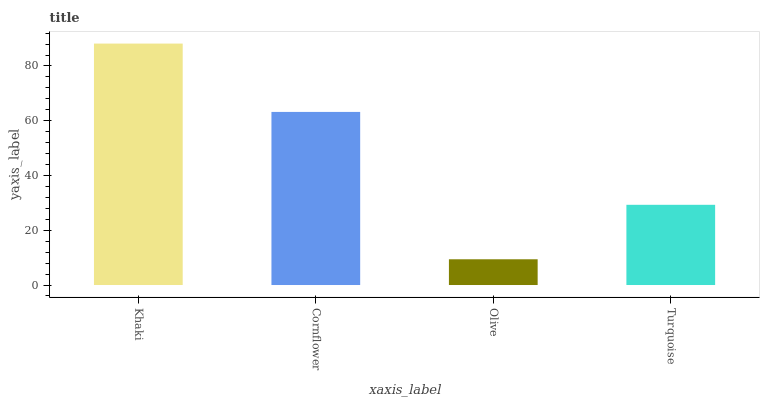Is Olive the minimum?
Answer yes or no. Yes. Is Khaki the maximum?
Answer yes or no. Yes. Is Cornflower the minimum?
Answer yes or no. No. Is Cornflower the maximum?
Answer yes or no. No. Is Khaki greater than Cornflower?
Answer yes or no. Yes. Is Cornflower less than Khaki?
Answer yes or no. Yes. Is Cornflower greater than Khaki?
Answer yes or no. No. Is Khaki less than Cornflower?
Answer yes or no. No. Is Cornflower the high median?
Answer yes or no. Yes. Is Turquoise the low median?
Answer yes or no. Yes. Is Olive the high median?
Answer yes or no. No. Is Cornflower the low median?
Answer yes or no. No. 